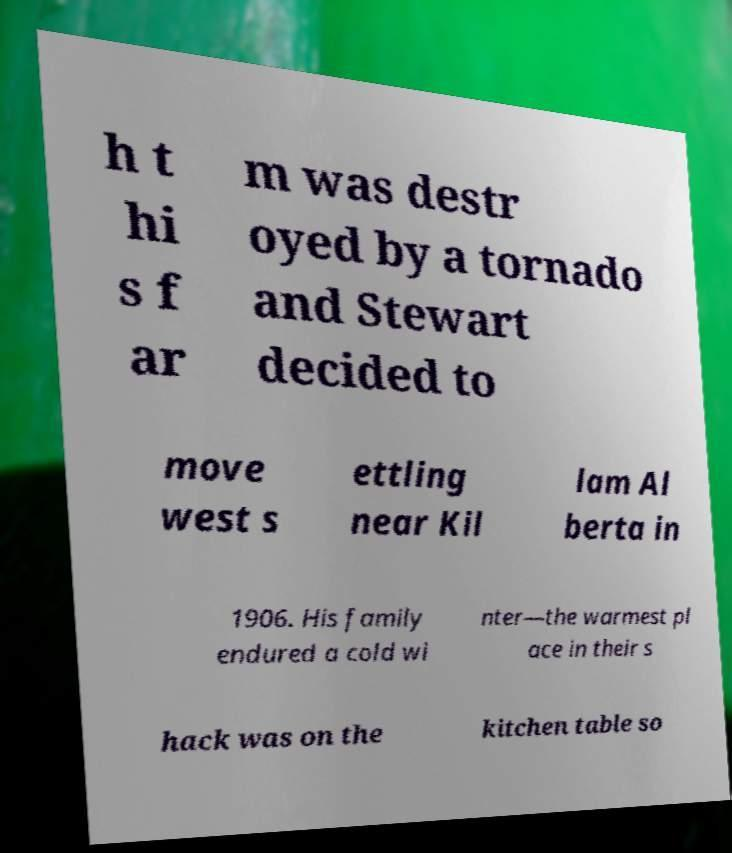Can you read and provide the text displayed in the image?This photo seems to have some interesting text. Can you extract and type it out for me? h t hi s f ar m was destr oyed by a tornado and Stewart decided to move west s ettling near Kil lam Al berta in 1906. His family endured a cold wi nter—the warmest pl ace in their s hack was on the kitchen table so 